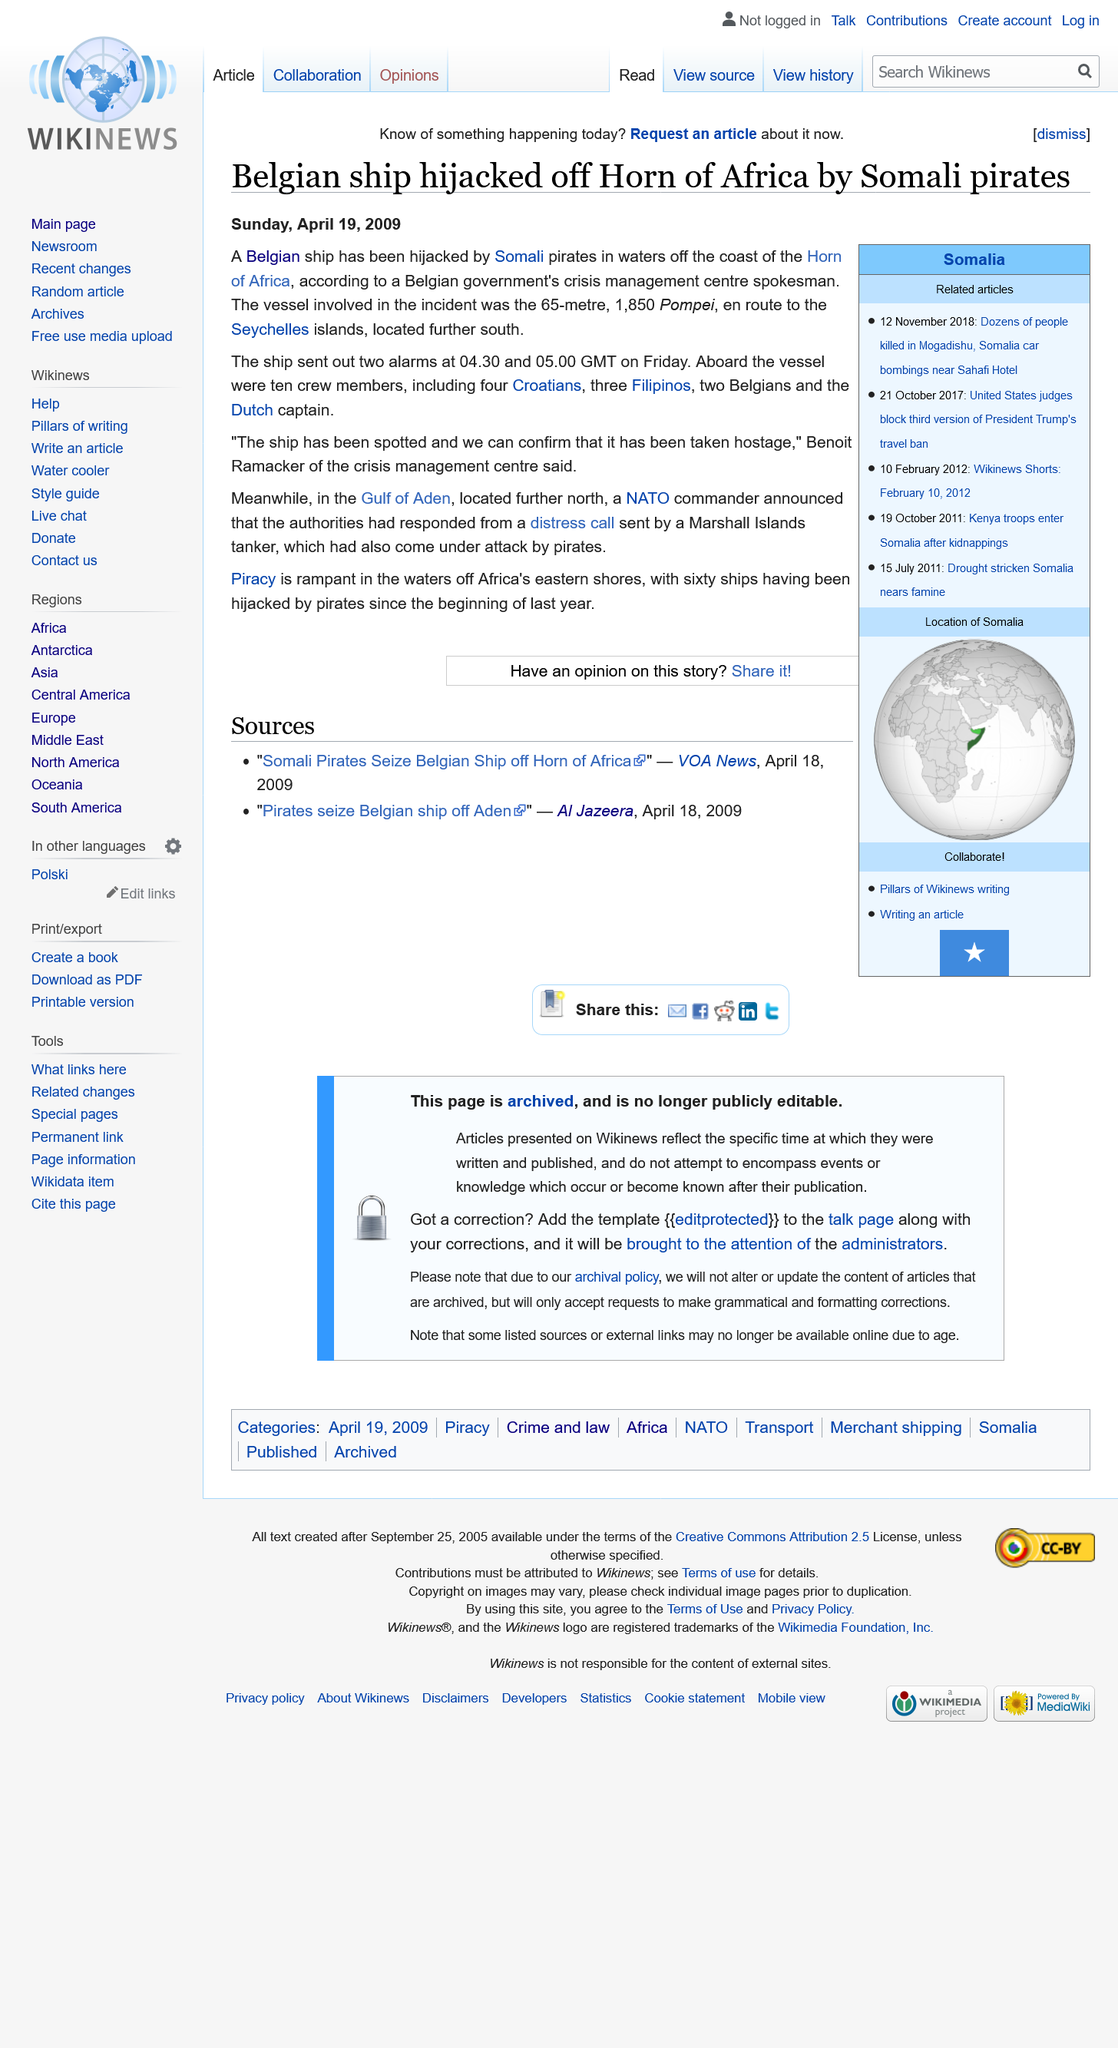Outline some significant characteristics in this image. The hijacking occurred with 10 crew members on board the vessel. The Belgian ship was hijacked by Somali pirates off the Horn of Africa. The Belgian ship was en route to the Seychelles islands when it was hijacked. 